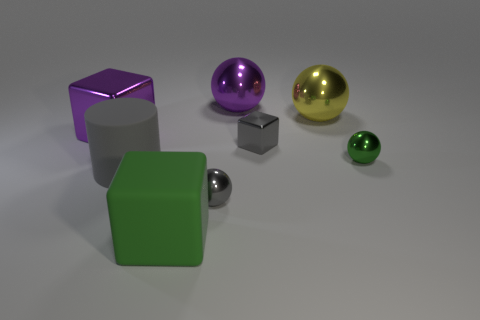The gray ball has what size?
Offer a very short reply. Small. The object left of the cylinder has what shape?
Keep it short and to the point. Cube. Do the yellow shiny thing and the small green thing have the same shape?
Provide a succinct answer. Yes. Are there an equal number of shiny objects to the right of the small green metal sphere and large blue matte spheres?
Your response must be concise. Yes. There is a small green object; what shape is it?
Provide a succinct answer. Sphere. Is there anything else of the same color as the big matte block?
Offer a terse response. Yes. Do the purple metal object in front of the large yellow thing and the gray metallic object that is left of the large purple sphere have the same size?
Your answer should be very brief. No. What shape is the purple shiny thing right of the tiny thing that is in front of the gray cylinder?
Offer a very short reply. Sphere. Do the purple metal block and the gray shiny thing in front of the gray cube have the same size?
Make the answer very short. No. There is a purple block that is behind the green object to the right of the large yellow sphere that is on the right side of the purple block; what is its size?
Offer a very short reply. Large. 